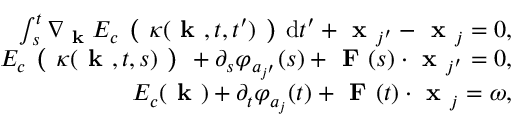<formula> <loc_0><loc_0><loc_500><loc_500>\begin{array} { r } { \int _ { s } ^ { t } \nabla _ { k } E _ { c } ( \kappa ( k , t , t ^ { \prime } ) ) d t ^ { \prime } + x _ { j ^ { \prime } } - x _ { j } = 0 , } \\ { E _ { c } ( \kappa ( k , t , s ) ) + \partial _ { s } \varphi _ { a _ { j ^ { \prime } } } ( s ) + F ( s ) \cdot x _ { j ^ { \prime } } = 0 , } \\ { E _ { c } ( k ) + \partial _ { t } \varphi _ { a _ { j } } ( t ) + F ( t ) \cdot x _ { j } = \omega , } \end{array}</formula> 